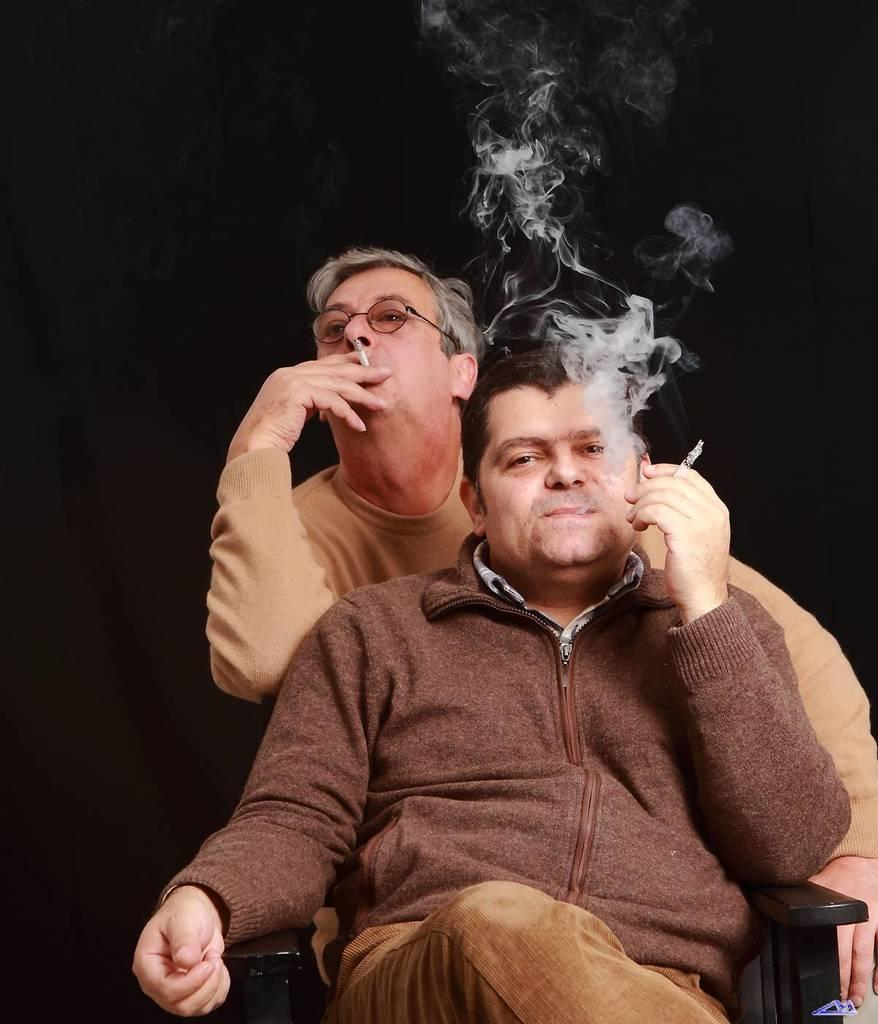How many people are in the image? There are two men in the image. What are the men doing in the image? The men are smoking in the image. What is the position of one of the men? One man is sitting on a chair. What can be seen in the image as a result of the men smoking? Smoke is visible in the image. How would you describe the lighting in the image? The background of the image is dark. Can you see a goose swimming in the sea in the image? There is no goose or sea present in the image. What direction are the men walking in the image? The men are not walking in the image; they are sitting and smoking. 